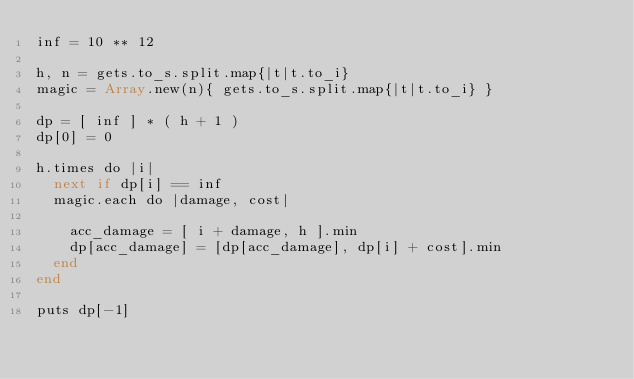Convert code to text. <code><loc_0><loc_0><loc_500><loc_500><_Crystal_>inf = 10 ** 12

h, n = gets.to_s.split.map{|t|t.to_i}
magic = Array.new(n){ gets.to_s.split.map{|t|t.to_i} }

dp = [ inf ] * ( h + 1 )
dp[0] = 0

h.times do |i|
  next if dp[i] == inf
  magic.each do |damage, cost|
    
    acc_damage = [ i + damage, h ].min
    dp[acc_damage] = [dp[acc_damage], dp[i] + cost].min
  end
end

puts dp[-1]</code> 